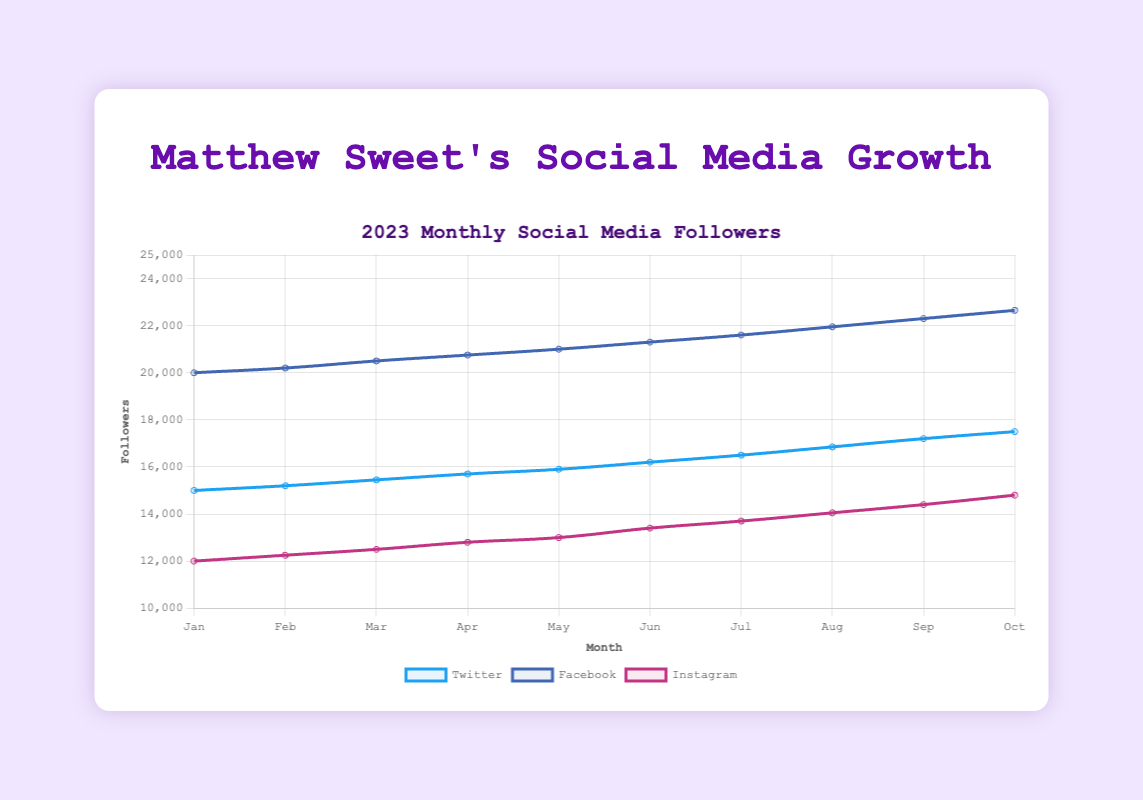What is the trend of Matthew Sweet's Twitter followers over the given months? By looking at the line labeled 'Twitter' from January to October, we can see a consistent upward trend, indicating a steady increase in followers over time.
Answer: Upward How many Facebook followers did Matthew Sweet have in August 2023? By locating the point corresponding to August 2023 on the line labeled 'Facebook', we see the value is 21,950 followers.
Answer: 21,950 Which month had the highest growth in Instagram followers for Matthew Sweet? Comparing the slopes (steepness) of the 'Instagram' line between each month, May to June has the highest growth, with followers increasing from 13,000 to 13,400.
Answer: June Compare the number of Twitter followers in January and October 2023. How many more followers does Matthew Sweet have in October compared to January? Subtract the number of Twitter followers in January (15,000) from the number in October (17,500): 17,500 - 15,000 = 2,500.
Answer: 2,500 What's the average number of Facebook followers from January to October 2023? Sum the Facebook followers for each month and divide by 10. (20000 + 20200 + 20500 + 20750 + 21000 + 21300 + 21600 + 21950 + 22300 + 22650) / 10 = 21,125.
Answer: 21,125 On which social media platform did Matthew Sweet gain the most followers from January to October 2023? Calculate the difference in followers from January to October for each platform: Twitter (17,500 - 15,000 = 2,500), Facebook (22,650 - 20,000 = 2,650), Instagram (14,800 - 12,000 = 2,800). Instagram has the highest gain.
Answer: Instagram How does the number of Instagram followers in April 2023 compare to the number of Twitter followers in the same month? For April, Instagram has 12,800 followers whereas Twitter has 15,700 followers. Comparing these, Twitter has 2,900 more followers than Instagram.
Answer: Twitter has 2,900 more What's the percentage increase in Twitter followers from January to July 2023? Calculate the increase: 16,500 (July) - 15,000 (January) = 1,500. Then, divide by the initial value and multiply by 100: (1,500 / 15,000) * 100 = 10%.
Answer: 10% Which month shows the smallest increase in Facebook followers compared to the previous month? By comparing the differences in followers between consecutive months for Facebook, from March to April, the increase is the smallest: 20,750 - 20,500 = 250.
Answer: April 